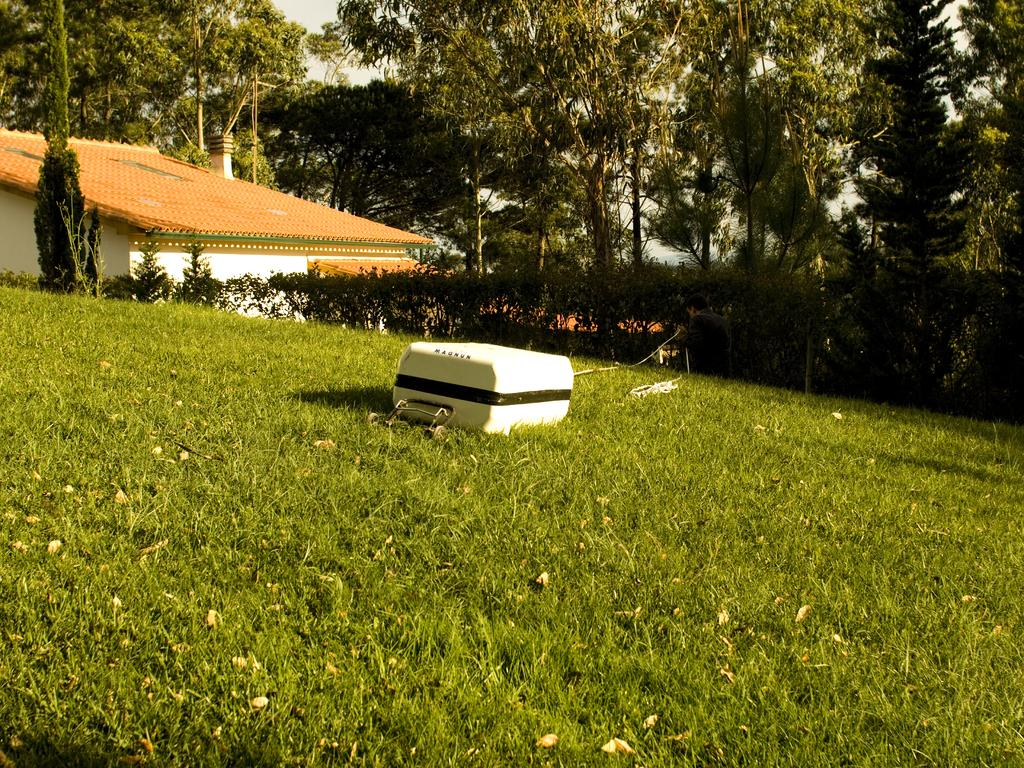What type of surface is visible in the image? There is a grass surface in the image. What object can be seen on the grass surface? There is a white box in the image. What type of vegetation is visible in the image? There are plants, trees, and a house visible in the image. What structures are present in the image? There are poles in the image. What part of the natural environment is visible in the image? The sky is partially visible in the image. What type of oil is being used by the judge in the image? There is no judge or oil present in the image. How does the cough sound coming from the trees in the image? There is no cough or sound coming from the trees in the image. 